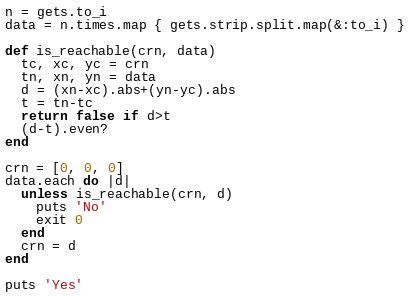<code> <loc_0><loc_0><loc_500><loc_500><_Ruby_>n = gets.to_i
data = n.times.map { gets.strip.split.map(&:to_i) }

def is_reachable(crn, data)
  tc, xc, yc = crn
  tn, xn, yn = data
  d = (xn-xc).abs+(yn-yc).abs
  t = tn-tc
  return false if d>t
  (d-t).even?
end

crn = [0, 0, 0]
data.each do |d|
  unless is_reachable(crn, d)
    puts 'No'
    exit 0
  end
  crn = d
end

puts 'Yes'</code> 